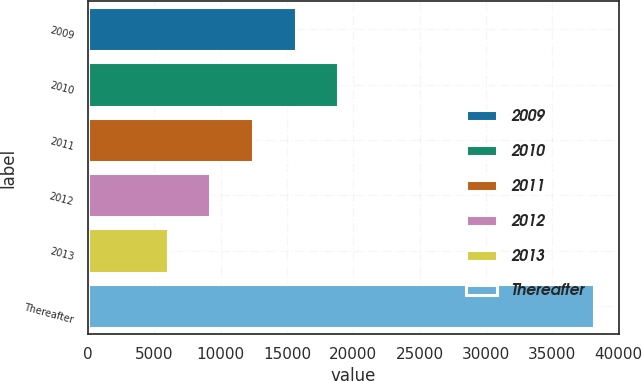Convert chart. <chart><loc_0><loc_0><loc_500><loc_500><bar_chart><fcel>2009<fcel>2010<fcel>2011<fcel>2012<fcel>2013<fcel>Thereafter<nl><fcel>15657.2<fcel>18867.6<fcel>12446.8<fcel>9236.4<fcel>6026<fcel>38130<nl></chart> 